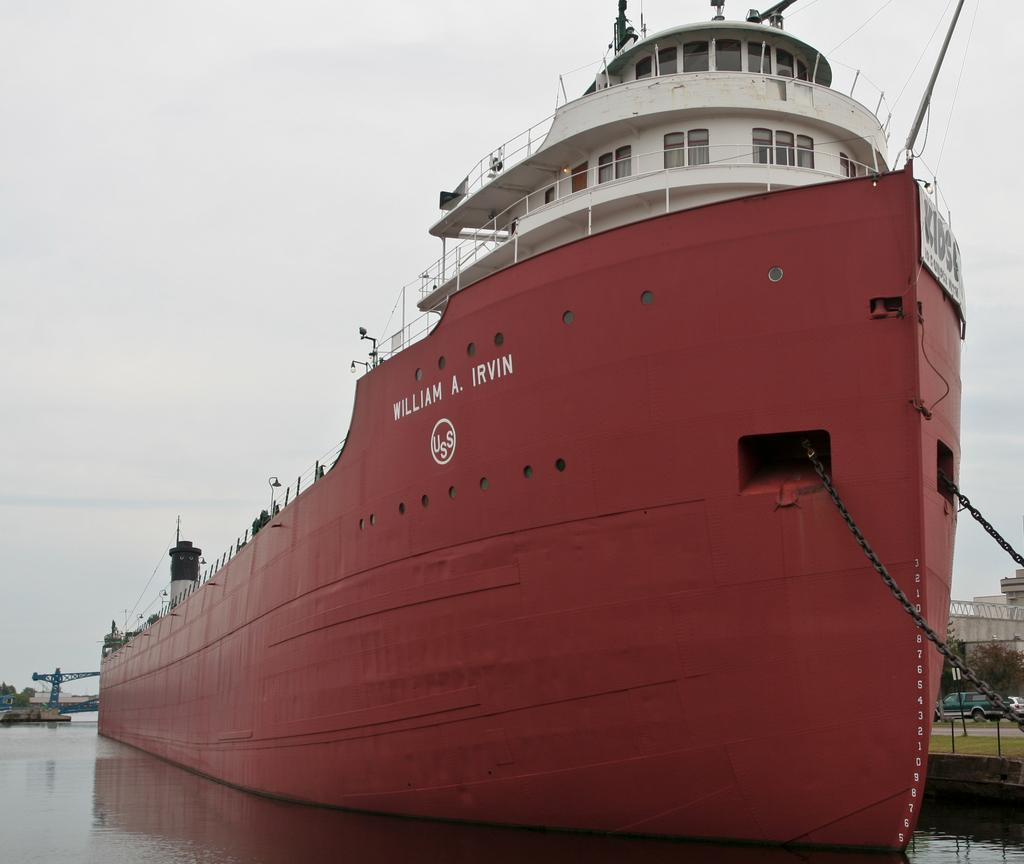What is in the water in the image? There are boats in the water in the image. What can be seen in the background of the image? Trees, vehicles, buildings, and the sky are visible in the background of the image. What might be the time of day when the image was taken? The image is likely taken during the day, as the sky is visible. What type of smell can be detected from the image? There is no information about smells in the image, as it is a visual medium. 